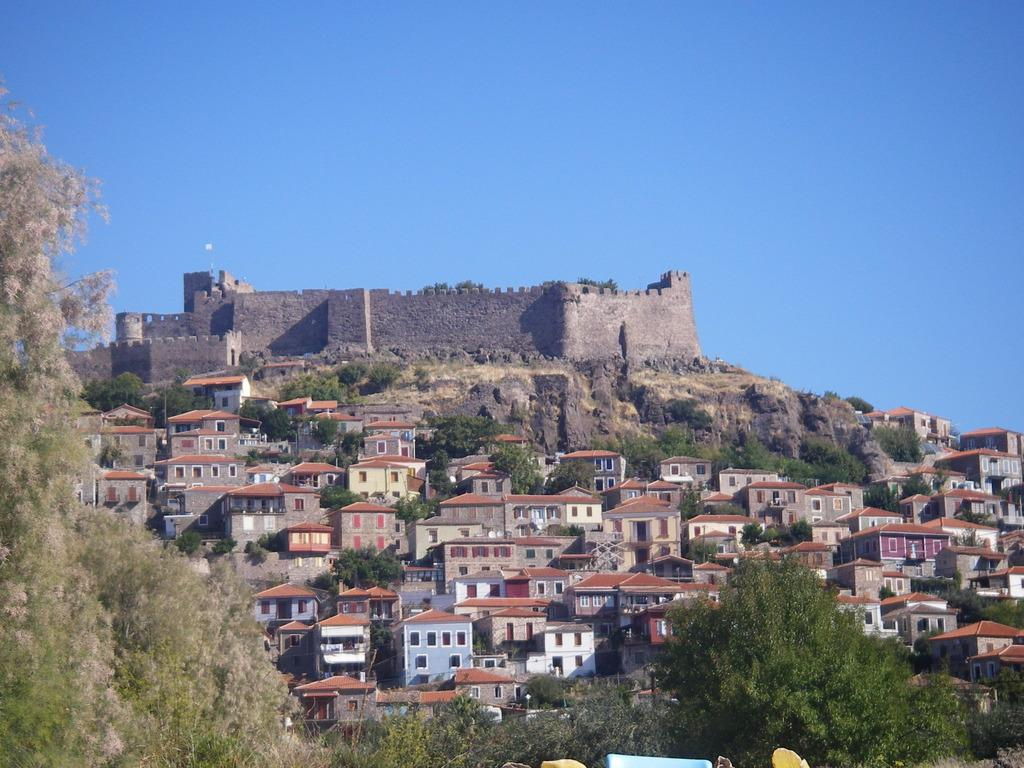What type of vegetation is visible in the image? There are trees in front of the image and more trees in the middle of the image. What type of structures can be seen in the image? There are buildings in the middle of the image. What is visible in the background of the image? The sky is visible in the background of the image. What is the condition of the sky in the image? The sky is clear in the image. What type of whip is being used to clean the sheet in the image? There is no whip or sheet present in the image. Where is the home located in the image? There is no home mentioned or visible in the image. 